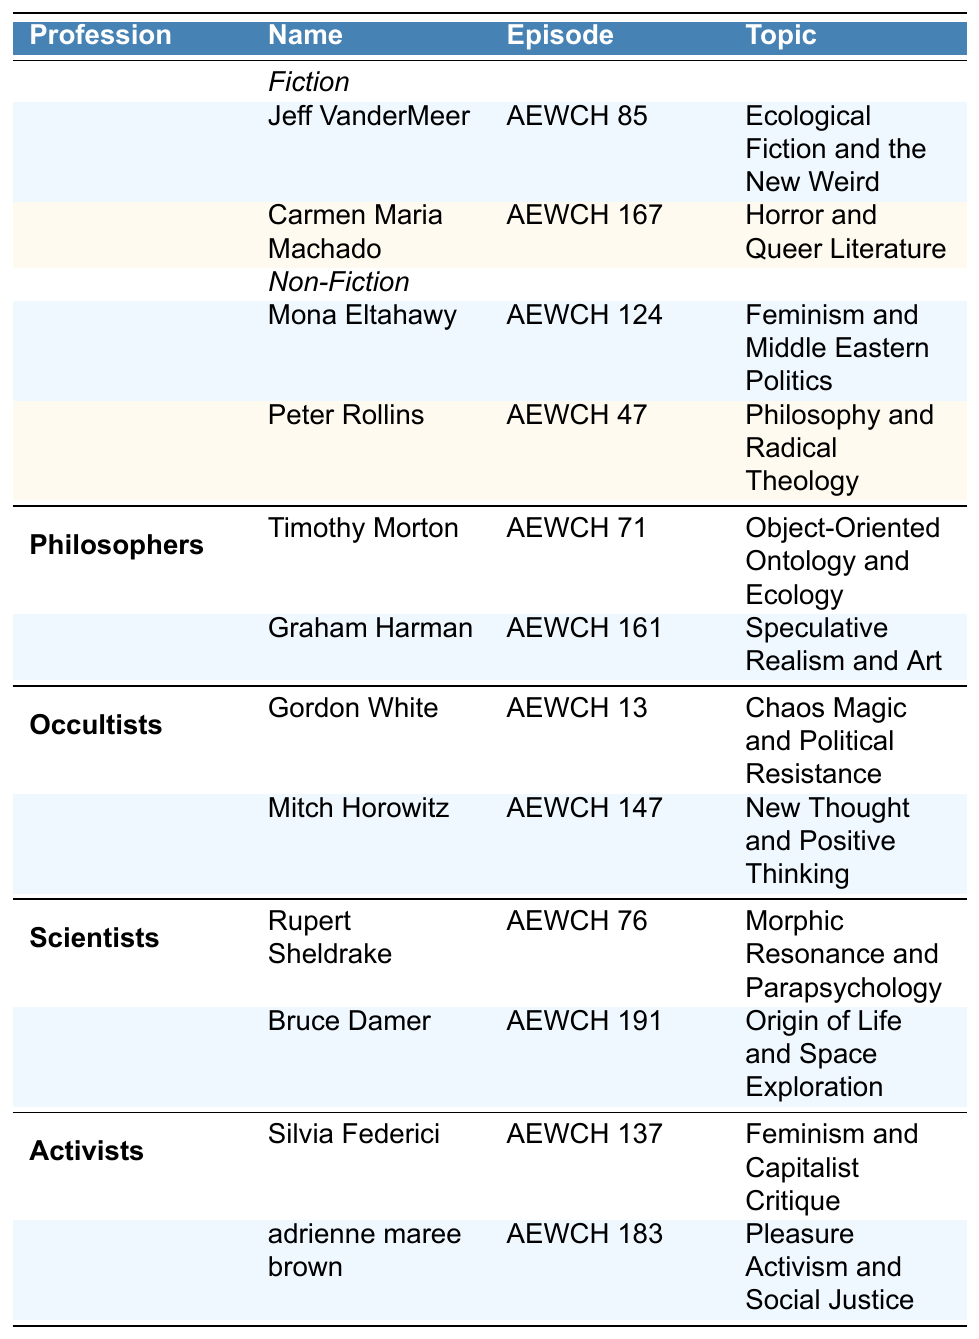Which guest appeared on episode AEWCH 85? The table shows that Jeff VanderMeer is listed under "Authors" in the "Fiction" category for episode AEWCH 85.
Answer: Jeff VanderMeer How many guests are categorized as Activists? The table indicates that there are two guests listed under the Activists category: Silvia Federici and adrienne maree brown.
Answer: 2 What topic did Carmen Maria Machado discuss? From the table, it is clear that Carmen Maria Machado spoke about "Horror and Queer Literature" in episode AEWCH 167.
Answer: Horror and Queer Literature Is there a guest named Bruce Damer? Referring to the table, Bruce Damer is indeed listed, categorized under Scientists for episode AEWCH 191.
Answer: Yes Which profession has the most guests listed? By examining the table, the Authors category has four guests (two in Fiction and two in Non-Fiction), while others have two each. Thus, Authors have the most guests.
Answer: Authors What are the topics of the guests in the Occultists category? The table provides the relevant information where Gordon White discusses "Chaos Magic and Political Resistance," and Mitch Horowitz talks about "New Thought and Positive Thinking."
Answer: Chaos Magic and Political Resistance, New Thought and Positive Thinking Which guest's topic relates to feminism? The table indicates that both Silvia Federici ("Feminism and Capitalist Critique") and Mona Eltahawy ("Feminism and Middle Eastern Politics") discuss feminism-related topics.
Answer: Silvia Federici, Mona Eltahawy What is the difference in the number of guests between Authors and Philosophers? There are four guests under Authors (2 Fiction + 2 Non-Fiction) and two guests under Philosophers. The difference is 4 - 2 = 2.
Answer: 2 Are there more guests discussing Fiction or Non-Fiction topics among Authors? In the table, there are two guests in both Fiction and Non-Fiction. Therefore, the number is the same.
Answer: Same number What topic related to ecology is discussed by Timothy Morton? The table states that Timothy Morton discusses "Object-Oriented Ontology and Ecology" in episode AEWCH 71.
Answer: Object-Oriented Ontology and Ecology 